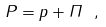Convert formula to latex. <formula><loc_0><loc_0><loc_500><loc_500>P = p + \Pi \ ,</formula> 